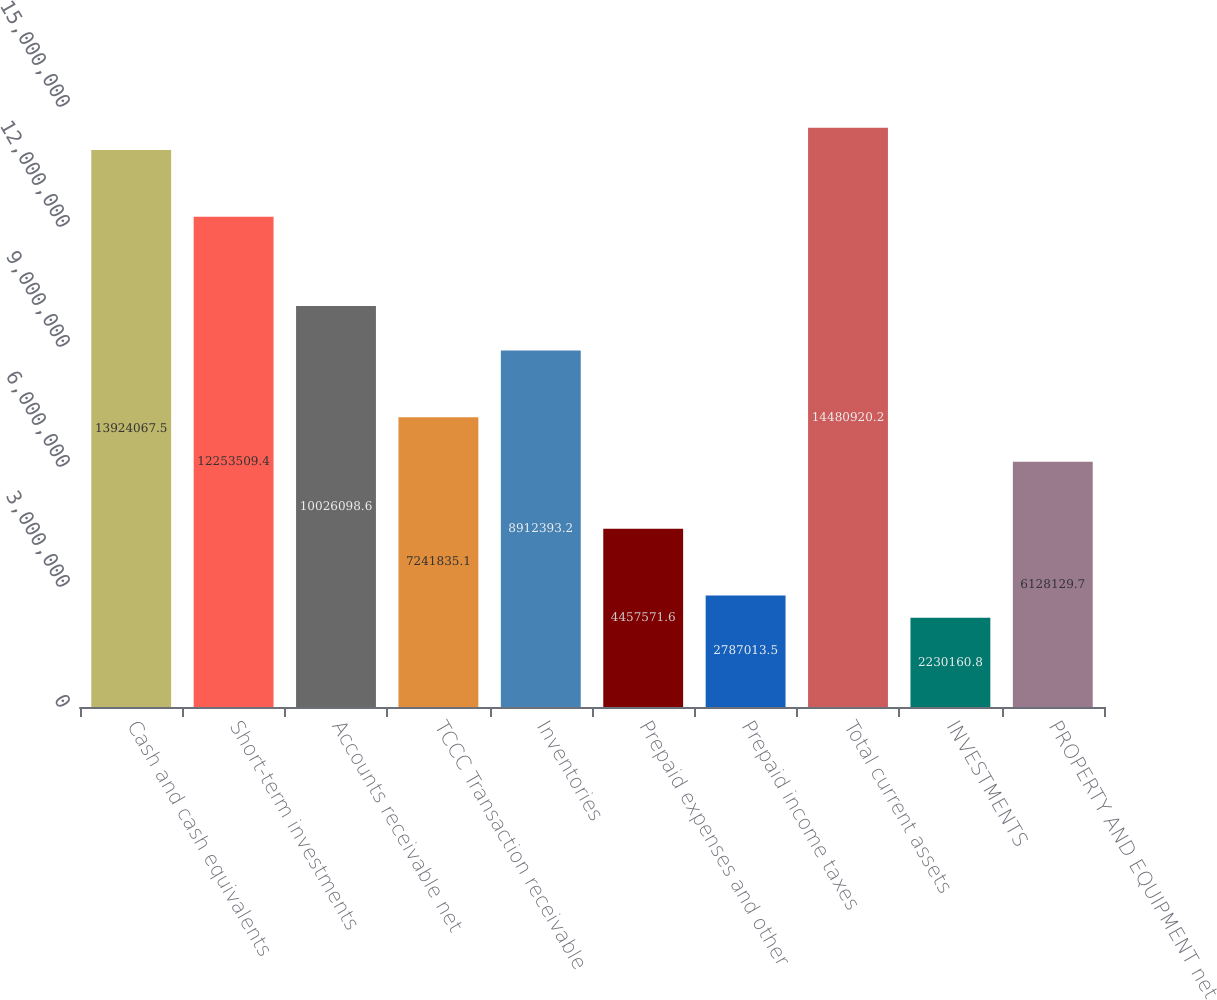<chart> <loc_0><loc_0><loc_500><loc_500><bar_chart><fcel>Cash and cash equivalents<fcel>Short-term investments<fcel>Accounts receivable net<fcel>TCCC Transaction receivable<fcel>Inventories<fcel>Prepaid expenses and other<fcel>Prepaid income taxes<fcel>Total current assets<fcel>INVESTMENTS<fcel>PROPERTY AND EQUIPMENT net<nl><fcel>1.39241e+07<fcel>1.22535e+07<fcel>1.00261e+07<fcel>7.24184e+06<fcel>8.91239e+06<fcel>4.45757e+06<fcel>2.78701e+06<fcel>1.44809e+07<fcel>2.23016e+06<fcel>6.12813e+06<nl></chart> 